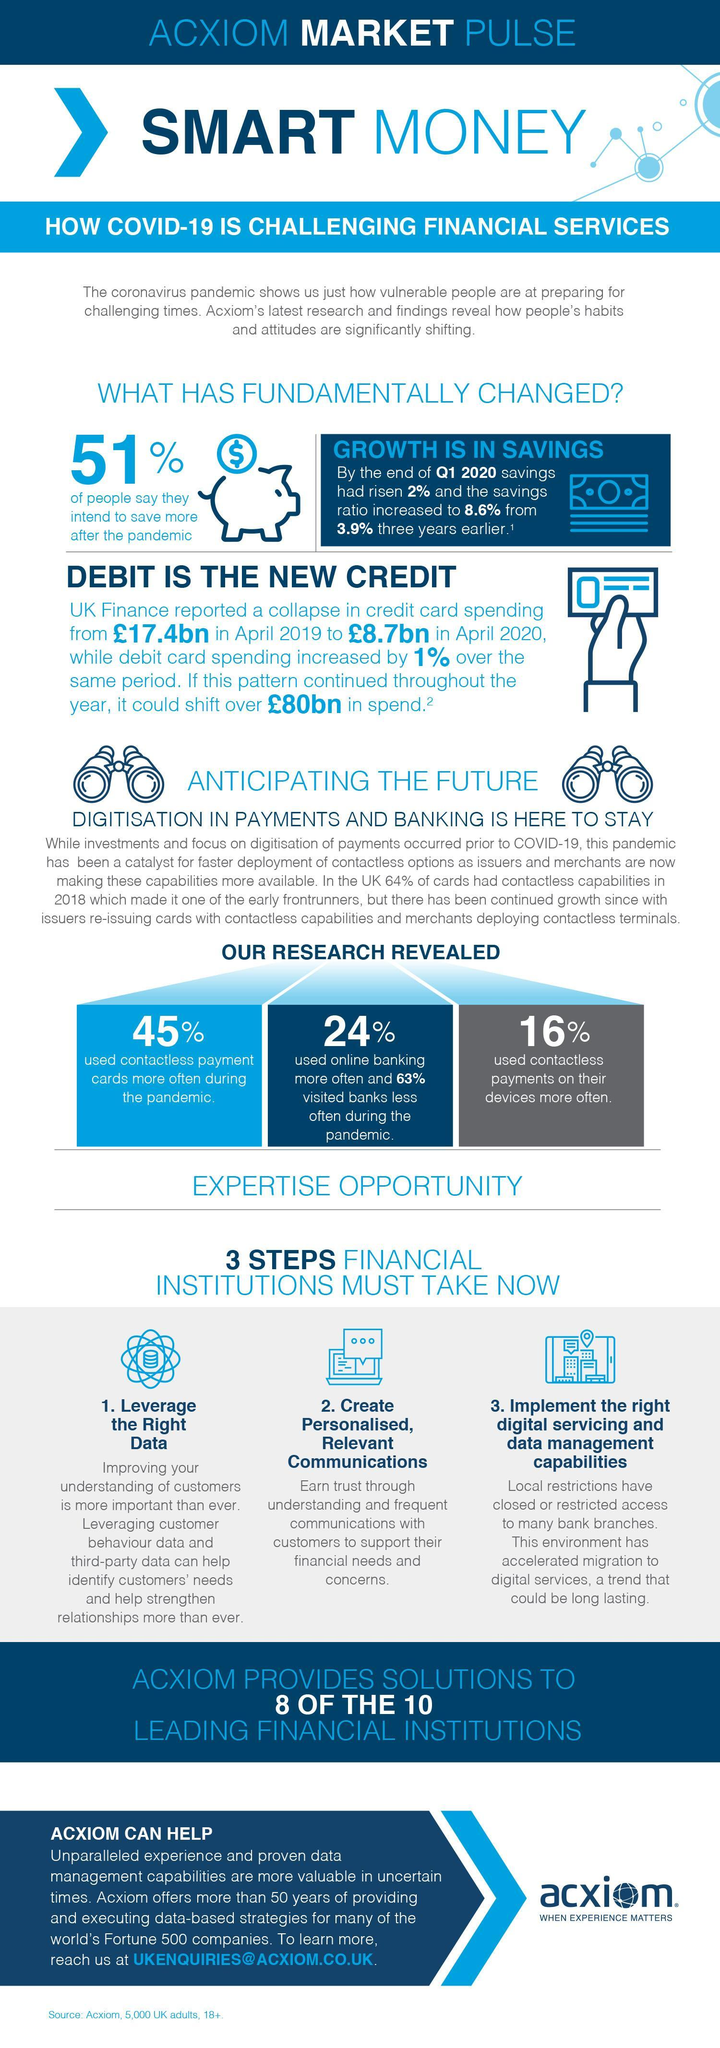How many of the people used contactless payment on their devices?
Answer the question with a short phrase. 16% What percent of people plan to save more after the pandemic? 51% How many of the people reduced their visits to banks? 63% How many of the people used contactless payment cards during the pandemic? 45% 